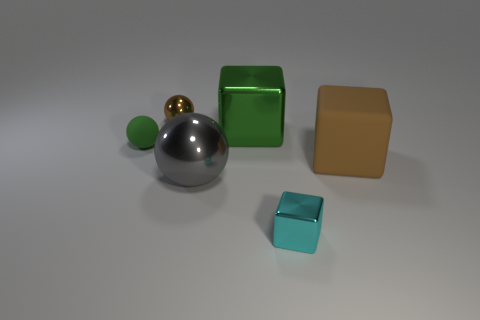Is there any other thing of the same color as the tiny matte ball?
Your answer should be very brief. Yes. What is the material of the green object that is right of the brown shiny thing behind the cube that is behind the large brown cube?
Your response must be concise. Metal. Does the large gray shiny object have the same shape as the small brown shiny object?
Make the answer very short. Yes. How many tiny things are to the right of the gray thing and on the left side of the tiny cyan block?
Make the answer very short. 0. There is a small shiny thing that is to the right of the tiny metal object behind the tiny shiny block; what color is it?
Provide a short and direct response. Cyan. Are there the same number of metal objects in front of the big rubber cube and tiny brown rubber blocks?
Your answer should be compact. No. There is a tiny metal thing behind the shiny block behind the big brown thing; how many small brown shiny spheres are in front of it?
Your answer should be very brief. 0. What color is the large cube that is in front of the big green shiny block?
Ensure brevity in your answer.  Brown. What material is the thing that is both in front of the big green metal object and behind the large brown cube?
Provide a succinct answer. Rubber. How many big gray things are in front of the shiny cube that is behind the green sphere?
Offer a very short reply. 1. 